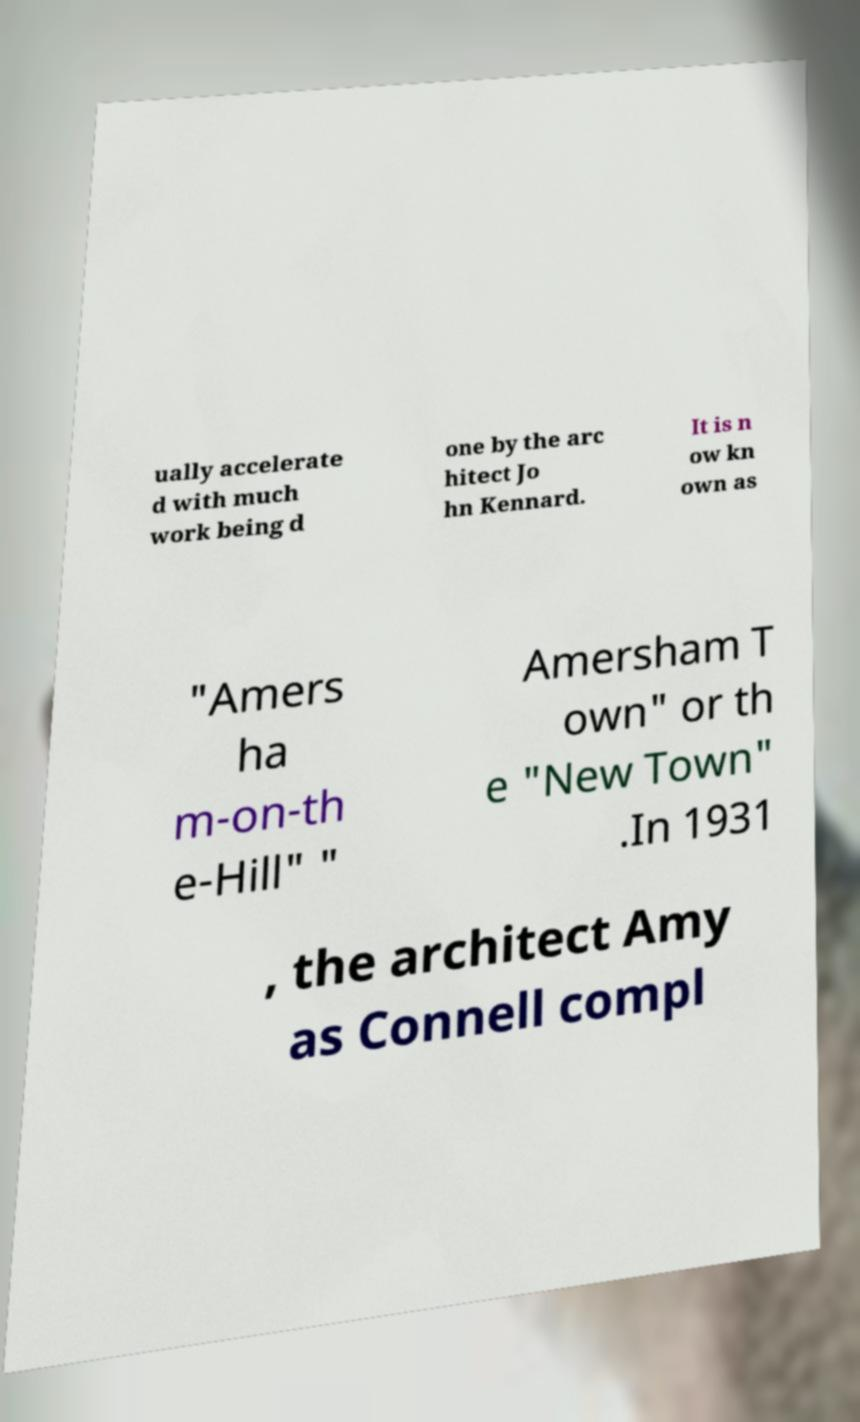There's text embedded in this image that I need extracted. Can you transcribe it verbatim? ually accelerate d with much work being d one by the arc hitect Jo hn Kennard. It is n ow kn own as "Amers ha m-on-th e-Hill" " Amersham T own" or th e "New Town" .In 1931 , the architect Amy as Connell compl 